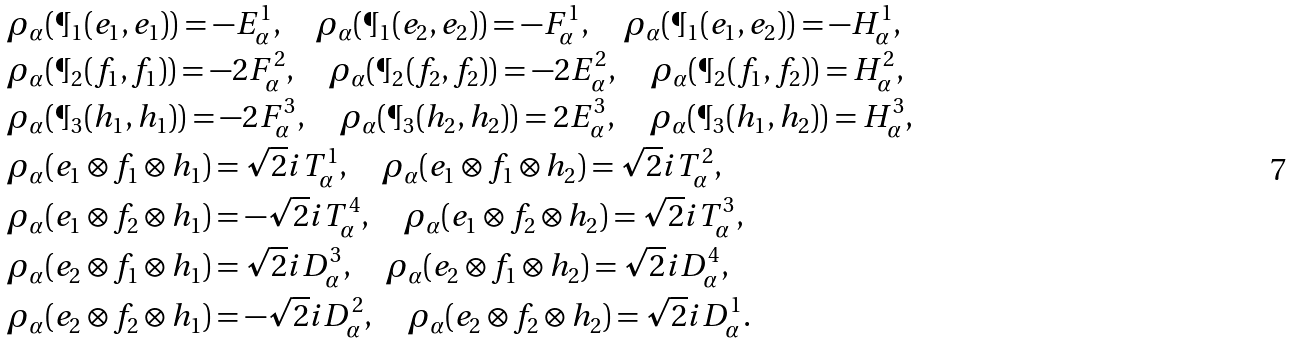Convert formula to latex. <formula><loc_0><loc_0><loc_500><loc_500>& \rho _ { \alpha } ( \P _ { 1 } ( e _ { 1 } , e _ { 1 } ) ) = - E _ { \alpha } ^ { 1 } , \quad \rho _ { \alpha } ( \P _ { 1 } ( e _ { 2 } , e _ { 2 } ) ) = - F _ { \alpha } ^ { 1 } , \quad \rho _ { \alpha } ( \P _ { 1 } ( e _ { 1 } , e _ { 2 } ) ) = - H _ { \alpha } ^ { 1 } , \\ & \rho _ { \alpha } ( \P _ { 2 } ( f _ { 1 } , f _ { 1 } ) ) = - 2 F _ { \alpha } ^ { 2 } , \quad \rho _ { \alpha } ( \P _ { 2 } ( f _ { 2 } , f _ { 2 } ) ) = - 2 E _ { \alpha } ^ { 2 } , \quad \rho _ { \alpha } ( \P _ { 2 } ( f _ { 1 } , f _ { 2 } ) ) = H _ { \alpha } ^ { 2 } , \\ & \rho _ { \alpha } ( \P _ { 3 } ( h _ { 1 } , h _ { 1 } ) ) = - 2 F _ { \alpha } ^ { 3 } , \quad \rho _ { \alpha } ( \P _ { 3 } ( h _ { 2 } , h _ { 2 } ) ) = 2 E _ { \alpha } ^ { 3 } , \quad \rho _ { \alpha } ( \P _ { 3 } ( h _ { 1 } , h _ { 2 } ) ) = H _ { \alpha } ^ { 3 } , \\ & \rho _ { \alpha } ( e _ { 1 } \otimes f _ { 1 } \otimes h _ { 1 } ) = { \sqrt { 2 } } i T _ { \alpha } ^ { 1 } , \quad \rho _ { \alpha } ( e _ { 1 } \otimes f _ { 1 } \otimes h _ { 2 } ) = { \sqrt { 2 } } i T _ { \alpha } ^ { 2 } , \\ & \rho _ { \alpha } ( e _ { 1 } \otimes f _ { 2 } \otimes h _ { 1 } ) = - { \sqrt { 2 } } i T _ { \alpha } ^ { 4 } , \quad \rho _ { \alpha } ( e _ { 1 } \otimes f _ { 2 } \otimes h _ { 2 } ) = { \sqrt { 2 } } i T _ { \alpha } ^ { 3 } , \\ & \rho _ { \alpha } ( e _ { 2 } \otimes f _ { 1 } \otimes h _ { 1 } ) = { \sqrt { 2 } } i D _ { \alpha } ^ { 3 } , \quad \rho _ { \alpha } ( e _ { 2 } \otimes f _ { 1 } \otimes h _ { 2 } ) = { \sqrt { 2 } } i D _ { \alpha } ^ { 4 } , \\ & \rho _ { \alpha } ( e _ { 2 } \otimes f _ { 2 } \otimes h _ { 1 } ) = - { \sqrt { 2 } } i D _ { \alpha } ^ { 2 } , \quad \rho _ { \alpha } ( e _ { 2 } \otimes f _ { 2 } \otimes h _ { 2 } ) = { \sqrt { 2 } } i D _ { \alpha } ^ { 1 } . \\</formula> 